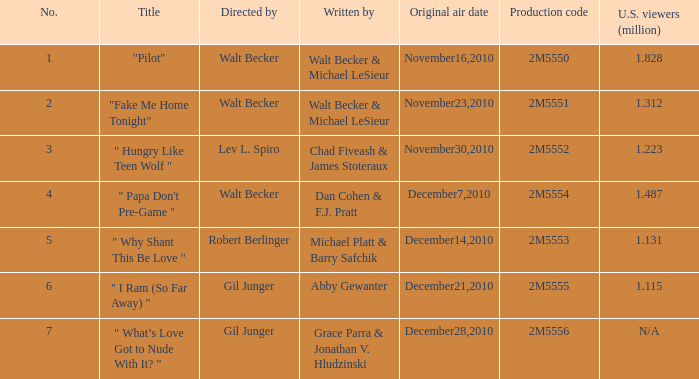Which episode number had 2.0. 